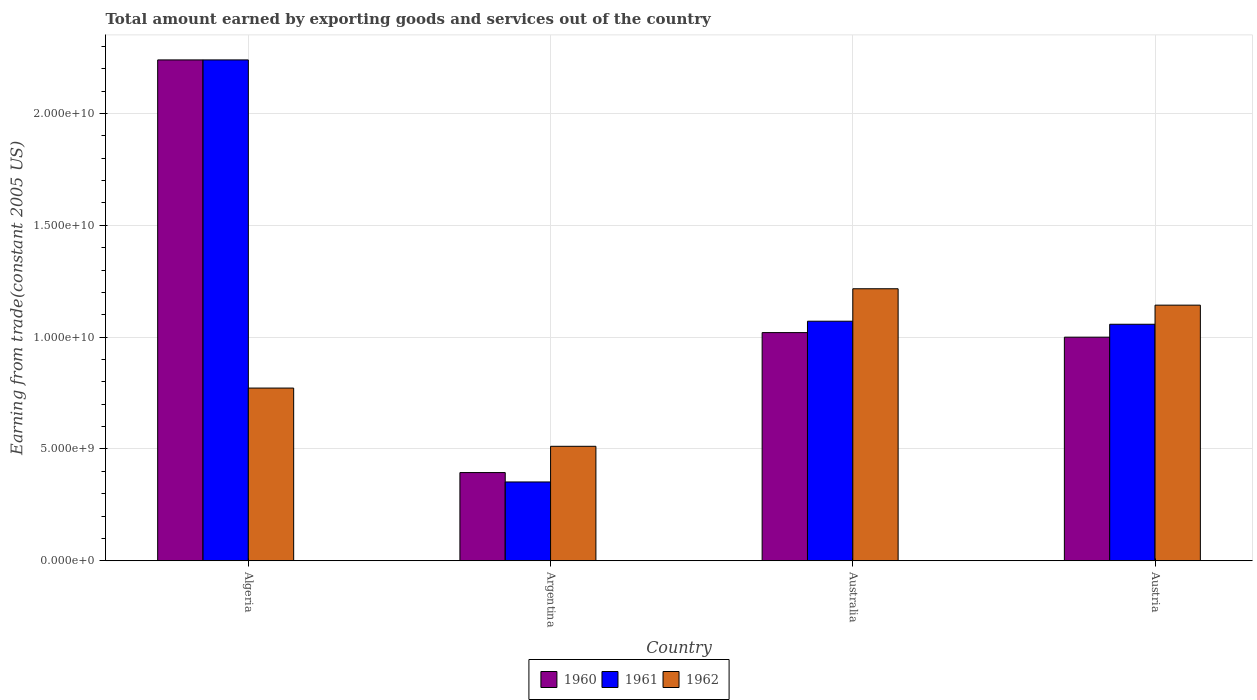How many groups of bars are there?
Your answer should be very brief. 4. Are the number of bars per tick equal to the number of legend labels?
Ensure brevity in your answer.  Yes. Are the number of bars on each tick of the X-axis equal?
Make the answer very short. Yes. How many bars are there on the 1st tick from the left?
Your answer should be compact. 3. What is the label of the 3rd group of bars from the left?
Provide a short and direct response. Australia. In how many cases, is the number of bars for a given country not equal to the number of legend labels?
Provide a succinct answer. 0. What is the total amount earned by exporting goods and services in 1961 in Austria?
Offer a terse response. 1.06e+1. Across all countries, what is the maximum total amount earned by exporting goods and services in 1961?
Your response must be concise. 2.24e+1. Across all countries, what is the minimum total amount earned by exporting goods and services in 1962?
Provide a succinct answer. 5.12e+09. What is the total total amount earned by exporting goods and services in 1961 in the graph?
Ensure brevity in your answer.  4.72e+1. What is the difference between the total amount earned by exporting goods and services in 1961 in Algeria and that in Argentina?
Keep it short and to the point. 1.89e+1. What is the difference between the total amount earned by exporting goods and services in 1961 in Argentina and the total amount earned by exporting goods and services in 1960 in Algeria?
Offer a terse response. -1.89e+1. What is the average total amount earned by exporting goods and services in 1962 per country?
Provide a succinct answer. 9.11e+09. What is the difference between the total amount earned by exporting goods and services of/in 1962 and total amount earned by exporting goods and services of/in 1960 in Australia?
Give a very brief answer. 1.96e+09. What is the ratio of the total amount earned by exporting goods and services in 1961 in Australia to that in Austria?
Offer a terse response. 1.01. Is the total amount earned by exporting goods and services in 1962 in Algeria less than that in Argentina?
Your answer should be compact. No. Is the difference between the total amount earned by exporting goods and services in 1962 in Algeria and Austria greater than the difference between the total amount earned by exporting goods and services in 1960 in Algeria and Austria?
Offer a terse response. No. What is the difference between the highest and the second highest total amount earned by exporting goods and services in 1961?
Ensure brevity in your answer.  1.18e+1. What is the difference between the highest and the lowest total amount earned by exporting goods and services in 1961?
Provide a short and direct response. 1.89e+1. In how many countries, is the total amount earned by exporting goods and services in 1961 greater than the average total amount earned by exporting goods and services in 1961 taken over all countries?
Your answer should be very brief. 1. What does the 3rd bar from the left in Australia represents?
Your answer should be very brief. 1962. What does the 2nd bar from the right in Algeria represents?
Your answer should be compact. 1961. Is it the case that in every country, the sum of the total amount earned by exporting goods and services in 1960 and total amount earned by exporting goods and services in 1961 is greater than the total amount earned by exporting goods and services in 1962?
Give a very brief answer. Yes. How many bars are there?
Your answer should be very brief. 12. What is the difference between two consecutive major ticks on the Y-axis?
Ensure brevity in your answer.  5.00e+09. Are the values on the major ticks of Y-axis written in scientific E-notation?
Offer a terse response. Yes. Does the graph contain any zero values?
Keep it short and to the point. No. How many legend labels are there?
Your answer should be very brief. 3. What is the title of the graph?
Provide a short and direct response. Total amount earned by exporting goods and services out of the country. Does "1990" appear as one of the legend labels in the graph?
Your answer should be very brief. No. What is the label or title of the Y-axis?
Make the answer very short. Earning from trade(constant 2005 US). What is the Earning from trade(constant 2005 US) of 1960 in Algeria?
Provide a succinct answer. 2.24e+1. What is the Earning from trade(constant 2005 US) in 1961 in Algeria?
Ensure brevity in your answer.  2.24e+1. What is the Earning from trade(constant 2005 US) in 1962 in Algeria?
Your answer should be very brief. 7.72e+09. What is the Earning from trade(constant 2005 US) in 1960 in Argentina?
Provide a short and direct response. 3.94e+09. What is the Earning from trade(constant 2005 US) in 1961 in Argentina?
Provide a succinct answer. 3.52e+09. What is the Earning from trade(constant 2005 US) in 1962 in Argentina?
Make the answer very short. 5.12e+09. What is the Earning from trade(constant 2005 US) of 1960 in Australia?
Your answer should be compact. 1.02e+1. What is the Earning from trade(constant 2005 US) of 1961 in Australia?
Your answer should be compact. 1.07e+1. What is the Earning from trade(constant 2005 US) in 1962 in Australia?
Provide a short and direct response. 1.22e+1. What is the Earning from trade(constant 2005 US) of 1960 in Austria?
Your response must be concise. 1.00e+1. What is the Earning from trade(constant 2005 US) of 1961 in Austria?
Provide a short and direct response. 1.06e+1. What is the Earning from trade(constant 2005 US) in 1962 in Austria?
Your answer should be compact. 1.14e+1. Across all countries, what is the maximum Earning from trade(constant 2005 US) of 1960?
Make the answer very short. 2.24e+1. Across all countries, what is the maximum Earning from trade(constant 2005 US) of 1961?
Give a very brief answer. 2.24e+1. Across all countries, what is the maximum Earning from trade(constant 2005 US) in 1962?
Offer a terse response. 1.22e+1. Across all countries, what is the minimum Earning from trade(constant 2005 US) in 1960?
Make the answer very short. 3.94e+09. Across all countries, what is the minimum Earning from trade(constant 2005 US) in 1961?
Make the answer very short. 3.52e+09. Across all countries, what is the minimum Earning from trade(constant 2005 US) of 1962?
Give a very brief answer. 5.12e+09. What is the total Earning from trade(constant 2005 US) in 1960 in the graph?
Your answer should be compact. 4.65e+1. What is the total Earning from trade(constant 2005 US) of 1961 in the graph?
Your answer should be very brief. 4.72e+1. What is the total Earning from trade(constant 2005 US) of 1962 in the graph?
Provide a succinct answer. 3.64e+1. What is the difference between the Earning from trade(constant 2005 US) of 1960 in Algeria and that in Argentina?
Provide a succinct answer. 1.84e+1. What is the difference between the Earning from trade(constant 2005 US) in 1961 in Algeria and that in Argentina?
Make the answer very short. 1.89e+1. What is the difference between the Earning from trade(constant 2005 US) of 1962 in Algeria and that in Argentina?
Offer a terse response. 2.60e+09. What is the difference between the Earning from trade(constant 2005 US) of 1960 in Algeria and that in Australia?
Your response must be concise. 1.22e+1. What is the difference between the Earning from trade(constant 2005 US) of 1961 in Algeria and that in Australia?
Your response must be concise. 1.17e+1. What is the difference between the Earning from trade(constant 2005 US) in 1962 in Algeria and that in Australia?
Your answer should be very brief. -4.44e+09. What is the difference between the Earning from trade(constant 2005 US) in 1960 in Algeria and that in Austria?
Give a very brief answer. 1.24e+1. What is the difference between the Earning from trade(constant 2005 US) in 1961 in Algeria and that in Austria?
Ensure brevity in your answer.  1.18e+1. What is the difference between the Earning from trade(constant 2005 US) of 1962 in Algeria and that in Austria?
Keep it short and to the point. -3.71e+09. What is the difference between the Earning from trade(constant 2005 US) in 1960 in Argentina and that in Australia?
Ensure brevity in your answer.  -6.26e+09. What is the difference between the Earning from trade(constant 2005 US) in 1961 in Argentina and that in Australia?
Provide a short and direct response. -7.19e+09. What is the difference between the Earning from trade(constant 2005 US) of 1962 in Argentina and that in Australia?
Offer a terse response. -7.04e+09. What is the difference between the Earning from trade(constant 2005 US) in 1960 in Argentina and that in Austria?
Provide a succinct answer. -6.05e+09. What is the difference between the Earning from trade(constant 2005 US) in 1961 in Argentina and that in Austria?
Your answer should be compact. -7.05e+09. What is the difference between the Earning from trade(constant 2005 US) in 1962 in Argentina and that in Austria?
Your answer should be compact. -6.31e+09. What is the difference between the Earning from trade(constant 2005 US) of 1960 in Australia and that in Austria?
Provide a short and direct response. 2.04e+08. What is the difference between the Earning from trade(constant 2005 US) of 1961 in Australia and that in Austria?
Offer a very short reply. 1.36e+08. What is the difference between the Earning from trade(constant 2005 US) of 1962 in Australia and that in Austria?
Provide a succinct answer. 7.33e+08. What is the difference between the Earning from trade(constant 2005 US) of 1960 in Algeria and the Earning from trade(constant 2005 US) of 1961 in Argentina?
Ensure brevity in your answer.  1.89e+1. What is the difference between the Earning from trade(constant 2005 US) in 1960 in Algeria and the Earning from trade(constant 2005 US) in 1962 in Argentina?
Your response must be concise. 1.73e+1. What is the difference between the Earning from trade(constant 2005 US) in 1961 in Algeria and the Earning from trade(constant 2005 US) in 1962 in Argentina?
Your answer should be compact. 1.73e+1. What is the difference between the Earning from trade(constant 2005 US) in 1960 in Algeria and the Earning from trade(constant 2005 US) in 1961 in Australia?
Ensure brevity in your answer.  1.17e+1. What is the difference between the Earning from trade(constant 2005 US) in 1960 in Algeria and the Earning from trade(constant 2005 US) in 1962 in Australia?
Your answer should be very brief. 1.02e+1. What is the difference between the Earning from trade(constant 2005 US) of 1961 in Algeria and the Earning from trade(constant 2005 US) of 1962 in Australia?
Your response must be concise. 1.02e+1. What is the difference between the Earning from trade(constant 2005 US) in 1960 in Algeria and the Earning from trade(constant 2005 US) in 1961 in Austria?
Your response must be concise. 1.18e+1. What is the difference between the Earning from trade(constant 2005 US) in 1960 in Algeria and the Earning from trade(constant 2005 US) in 1962 in Austria?
Provide a succinct answer. 1.10e+1. What is the difference between the Earning from trade(constant 2005 US) of 1961 in Algeria and the Earning from trade(constant 2005 US) of 1962 in Austria?
Give a very brief answer. 1.10e+1. What is the difference between the Earning from trade(constant 2005 US) in 1960 in Argentina and the Earning from trade(constant 2005 US) in 1961 in Australia?
Give a very brief answer. -6.77e+09. What is the difference between the Earning from trade(constant 2005 US) in 1960 in Argentina and the Earning from trade(constant 2005 US) in 1962 in Australia?
Your response must be concise. -8.22e+09. What is the difference between the Earning from trade(constant 2005 US) in 1961 in Argentina and the Earning from trade(constant 2005 US) in 1962 in Australia?
Offer a terse response. -8.64e+09. What is the difference between the Earning from trade(constant 2005 US) in 1960 in Argentina and the Earning from trade(constant 2005 US) in 1961 in Austria?
Your answer should be compact. -6.63e+09. What is the difference between the Earning from trade(constant 2005 US) in 1960 in Argentina and the Earning from trade(constant 2005 US) in 1962 in Austria?
Give a very brief answer. -7.49e+09. What is the difference between the Earning from trade(constant 2005 US) in 1961 in Argentina and the Earning from trade(constant 2005 US) in 1962 in Austria?
Keep it short and to the point. -7.91e+09. What is the difference between the Earning from trade(constant 2005 US) of 1960 in Australia and the Earning from trade(constant 2005 US) of 1961 in Austria?
Offer a terse response. -3.73e+08. What is the difference between the Earning from trade(constant 2005 US) of 1960 in Australia and the Earning from trade(constant 2005 US) of 1962 in Austria?
Your answer should be very brief. -1.23e+09. What is the difference between the Earning from trade(constant 2005 US) in 1961 in Australia and the Earning from trade(constant 2005 US) in 1962 in Austria?
Your answer should be compact. -7.18e+08. What is the average Earning from trade(constant 2005 US) in 1960 per country?
Give a very brief answer. 1.16e+1. What is the average Earning from trade(constant 2005 US) of 1961 per country?
Your answer should be compact. 1.18e+1. What is the average Earning from trade(constant 2005 US) in 1962 per country?
Provide a succinct answer. 9.11e+09. What is the difference between the Earning from trade(constant 2005 US) in 1960 and Earning from trade(constant 2005 US) in 1961 in Algeria?
Keep it short and to the point. 0. What is the difference between the Earning from trade(constant 2005 US) in 1960 and Earning from trade(constant 2005 US) in 1962 in Algeria?
Your response must be concise. 1.47e+1. What is the difference between the Earning from trade(constant 2005 US) of 1961 and Earning from trade(constant 2005 US) of 1962 in Algeria?
Your answer should be compact. 1.47e+1. What is the difference between the Earning from trade(constant 2005 US) of 1960 and Earning from trade(constant 2005 US) of 1961 in Argentina?
Provide a succinct answer. 4.20e+08. What is the difference between the Earning from trade(constant 2005 US) in 1960 and Earning from trade(constant 2005 US) in 1962 in Argentina?
Ensure brevity in your answer.  -1.17e+09. What is the difference between the Earning from trade(constant 2005 US) of 1961 and Earning from trade(constant 2005 US) of 1962 in Argentina?
Make the answer very short. -1.59e+09. What is the difference between the Earning from trade(constant 2005 US) in 1960 and Earning from trade(constant 2005 US) in 1961 in Australia?
Ensure brevity in your answer.  -5.09e+08. What is the difference between the Earning from trade(constant 2005 US) in 1960 and Earning from trade(constant 2005 US) in 1962 in Australia?
Offer a very short reply. -1.96e+09. What is the difference between the Earning from trade(constant 2005 US) in 1961 and Earning from trade(constant 2005 US) in 1962 in Australia?
Offer a very short reply. -1.45e+09. What is the difference between the Earning from trade(constant 2005 US) in 1960 and Earning from trade(constant 2005 US) in 1961 in Austria?
Make the answer very short. -5.77e+08. What is the difference between the Earning from trade(constant 2005 US) in 1960 and Earning from trade(constant 2005 US) in 1962 in Austria?
Give a very brief answer. -1.43e+09. What is the difference between the Earning from trade(constant 2005 US) of 1961 and Earning from trade(constant 2005 US) of 1962 in Austria?
Ensure brevity in your answer.  -8.54e+08. What is the ratio of the Earning from trade(constant 2005 US) of 1960 in Algeria to that in Argentina?
Keep it short and to the point. 5.68. What is the ratio of the Earning from trade(constant 2005 US) of 1961 in Algeria to that in Argentina?
Provide a succinct answer. 6.35. What is the ratio of the Earning from trade(constant 2005 US) of 1962 in Algeria to that in Argentina?
Offer a very short reply. 1.51. What is the ratio of the Earning from trade(constant 2005 US) in 1960 in Algeria to that in Australia?
Your answer should be very brief. 2.19. What is the ratio of the Earning from trade(constant 2005 US) of 1961 in Algeria to that in Australia?
Offer a very short reply. 2.09. What is the ratio of the Earning from trade(constant 2005 US) in 1962 in Algeria to that in Australia?
Your response must be concise. 0.63. What is the ratio of the Earning from trade(constant 2005 US) in 1960 in Algeria to that in Austria?
Your answer should be compact. 2.24. What is the ratio of the Earning from trade(constant 2005 US) of 1961 in Algeria to that in Austria?
Ensure brevity in your answer.  2.12. What is the ratio of the Earning from trade(constant 2005 US) of 1962 in Algeria to that in Austria?
Ensure brevity in your answer.  0.68. What is the ratio of the Earning from trade(constant 2005 US) of 1960 in Argentina to that in Australia?
Ensure brevity in your answer.  0.39. What is the ratio of the Earning from trade(constant 2005 US) of 1961 in Argentina to that in Australia?
Keep it short and to the point. 0.33. What is the ratio of the Earning from trade(constant 2005 US) of 1962 in Argentina to that in Australia?
Ensure brevity in your answer.  0.42. What is the ratio of the Earning from trade(constant 2005 US) in 1960 in Argentina to that in Austria?
Offer a terse response. 0.39. What is the ratio of the Earning from trade(constant 2005 US) of 1961 in Argentina to that in Austria?
Your response must be concise. 0.33. What is the ratio of the Earning from trade(constant 2005 US) of 1962 in Argentina to that in Austria?
Provide a short and direct response. 0.45. What is the ratio of the Earning from trade(constant 2005 US) in 1960 in Australia to that in Austria?
Give a very brief answer. 1.02. What is the ratio of the Earning from trade(constant 2005 US) of 1961 in Australia to that in Austria?
Offer a terse response. 1.01. What is the ratio of the Earning from trade(constant 2005 US) in 1962 in Australia to that in Austria?
Your response must be concise. 1.06. What is the difference between the highest and the second highest Earning from trade(constant 2005 US) in 1960?
Keep it short and to the point. 1.22e+1. What is the difference between the highest and the second highest Earning from trade(constant 2005 US) of 1961?
Your answer should be compact. 1.17e+1. What is the difference between the highest and the second highest Earning from trade(constant 2005 US) of 1962?
Make the answer very short. 7.33e+08. What is the difference between the highest and the lowest Earning from trade(constant 2005 US) of 1960?
Your answer should be very brief. 1.84e+1. What is the difference between the highest and the lowest Earning from trade(constant 2005 US) of 1961?
Offer a terse response. 1.89e+1. What is the difference between the highest and the lowest Earning from trade(constant 2005 US) in 1962?
Offer a terse response. 7.04e+09. 